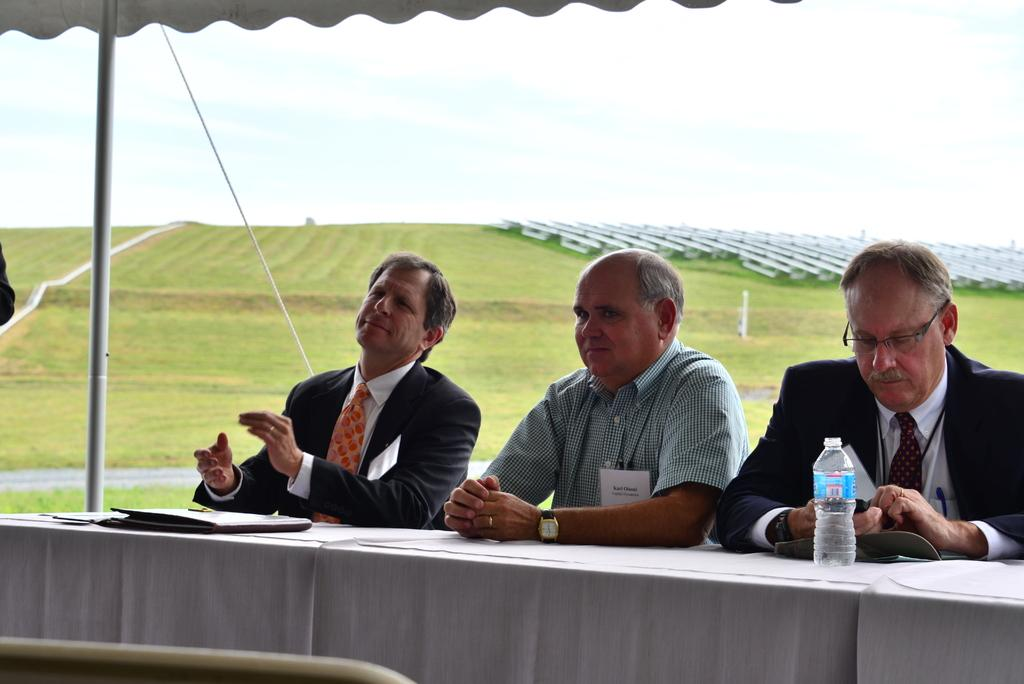How many people are sitting in front of the table in the image? There are three members sitting in front of the table in the image. What are the members sitting on? The members are sitting in chairs. What items can be seen on the table? There are files and a water bottle on the table. What can be seen in the background of the image? There is a ground visible in the background. What type of prose is being written on the canvas in the image? There is no canvas or prose present in the image. 